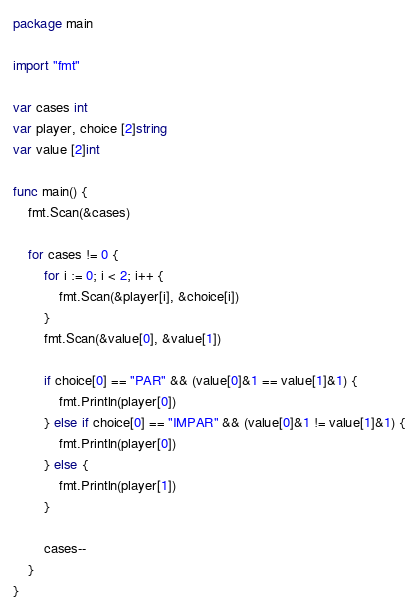<code> <loc_0><loc_0><loc_500><loc_500><_Go_>package main

import "fmt"

var cases int
var player, choice [2]string
var value [2]int

func main() {
	fmt.Scan(&cases)

	for cases != 0 {
		for i := 0; i < 2; i++ {
			fmt.Scan(&player[i], &choice[i])
		}
		fmt.Scan(&value[0], &value[1])

		if choice[0] == "PAR" && (value[0]&1 == value[1]&1) {
			fmt.Println(player[0])
		} else if choice[0] == "IMPAR" && (value[0]&1 != value[1]&1) {
			fmt.Println(player[0])
		} else {
			fmt.Println(player[1])
		}

		cases--
	}
}
</code> 